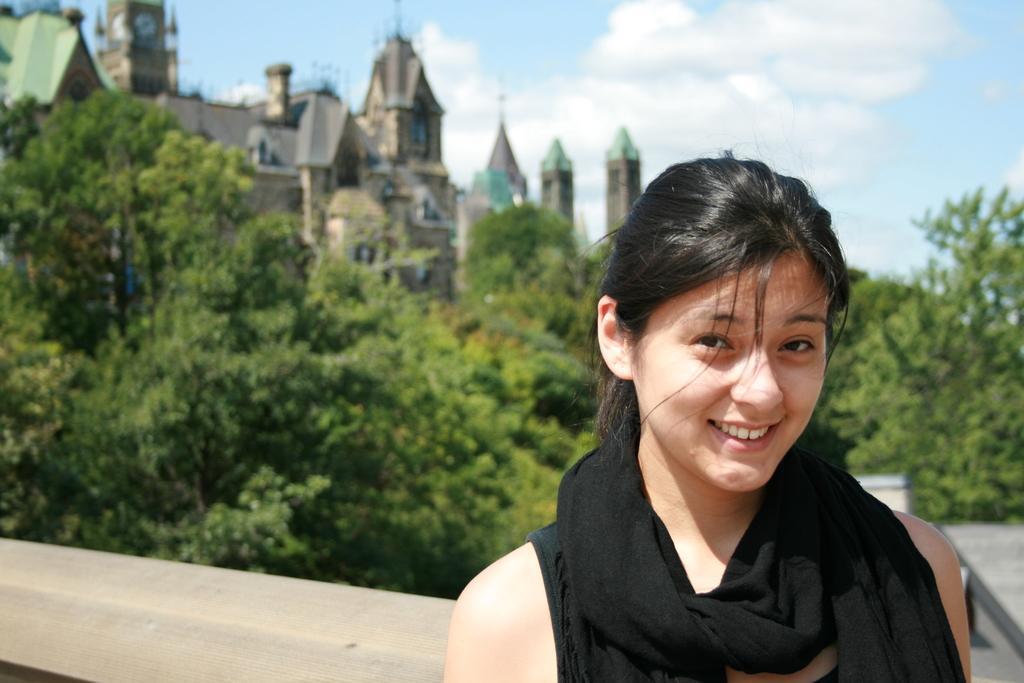How would you summarize this image in a sentence or two? In this image there is a woman standing with a smile on her face, behind her there are trees, buildings and the sky. 